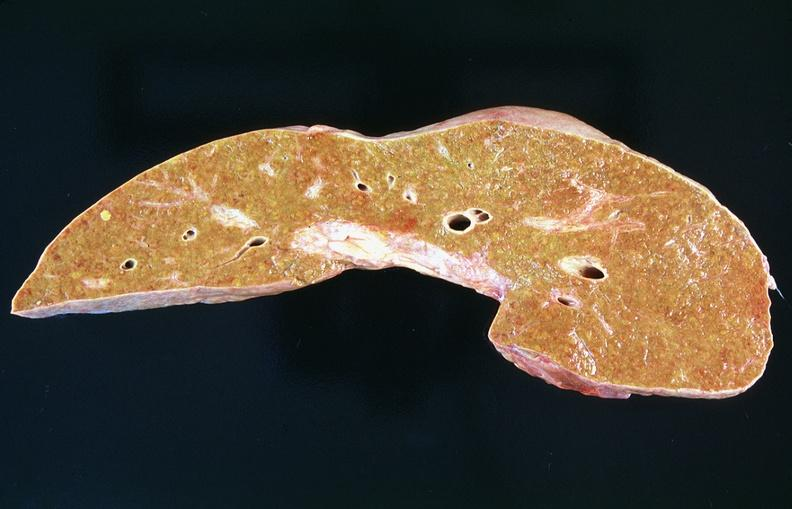does digital infarcts bacterial endocarditis show liver, cirrhosis alpha-1 antitrypsin deficiency?
Answer the question using a single word or phrase. No 